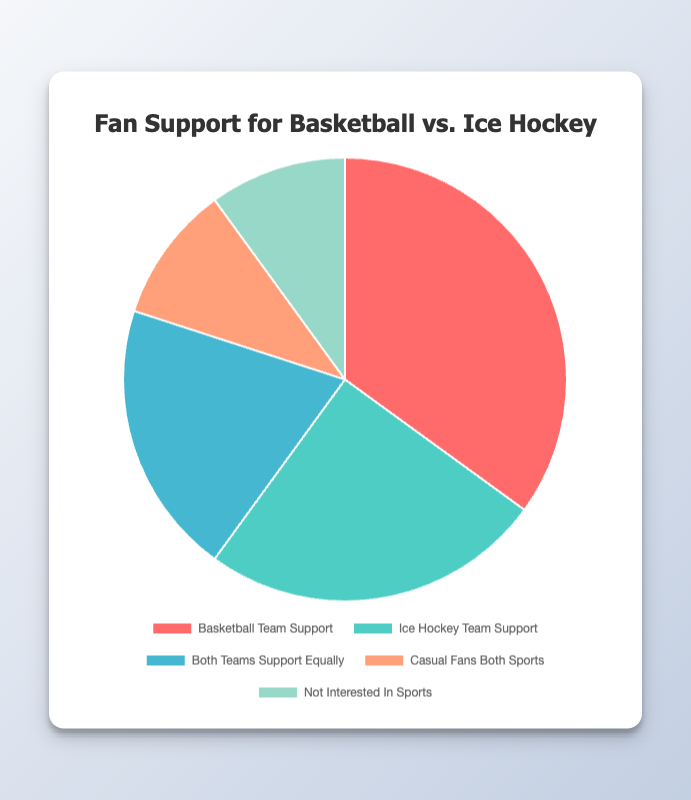Which team has the highest proportion of fan support? By observing the largest segment in the pie chart, representing 35% of the fan support, we can determine that the Basketball Team has the highest proportion.
Answer: Basketball Team What is the combined proportion of fans who either support both teams equally or are casual fans of both sports? We need to add the proportions of 'Both Teams Support Equally' (20%) and 'Casual Fans Both Sports' (10%), yielding 20% + 10% = 30%.
Answer: 30% How does the proportion of fans who support only the Ice Hockey team compare to those who support both teams equally? We compare the two proportions: 25% (Ice Hockey Team) versus 20% (Both Teams Support Equally). Since 25% is greater than 20%, the Ice Hockey Team has more exclusive support.
Answer: More What is the proportion of the community that is interested in at least one kind of sport (either basketball or ice hockey or both)? We need to subtract the 'Not Interested In Sports' proportion (10%) from 100%, leading to 100% - 10% = 90%.
Answer: 90% Which two segments are equal in proportion, and what is their percentage? By looking at the pie chart, 'Casual Fans Both Sports' and 'Not Interested In Sports' both occupy 10%.
Answer: Casual Fans Both Sports and Not Interested In Sports, 10% How much more is the support for the Basketball Team compared to the Ice Hockey Team? Subtract the proportion of the Ice Hockey Team (25%) from that of the Basketball Team (35%), giving 35% - 25% = 10%.
Answer: 10% What is the percentage of fans who support either the Basketball Team or the Ice Hockey Team but not both? Add the 'Basketball Team Support' (35%) and 'Ice Hockey Team Support' (25%) proportions, yielding 35% + 25% = 60%.
Answer: 60% What is the median value of the fan support proportions? Arrange the proportions in ascending order: 10%, 10%, 20%, 25%, 35%. The middle value is 20%.
Answer: 20% Which segment is represented by the color red, and what's its proportion? The segment with the largest proportion is colored red, representing the Basketball Team Support with 35%.
Answer: Basketball Team Support, 35% 